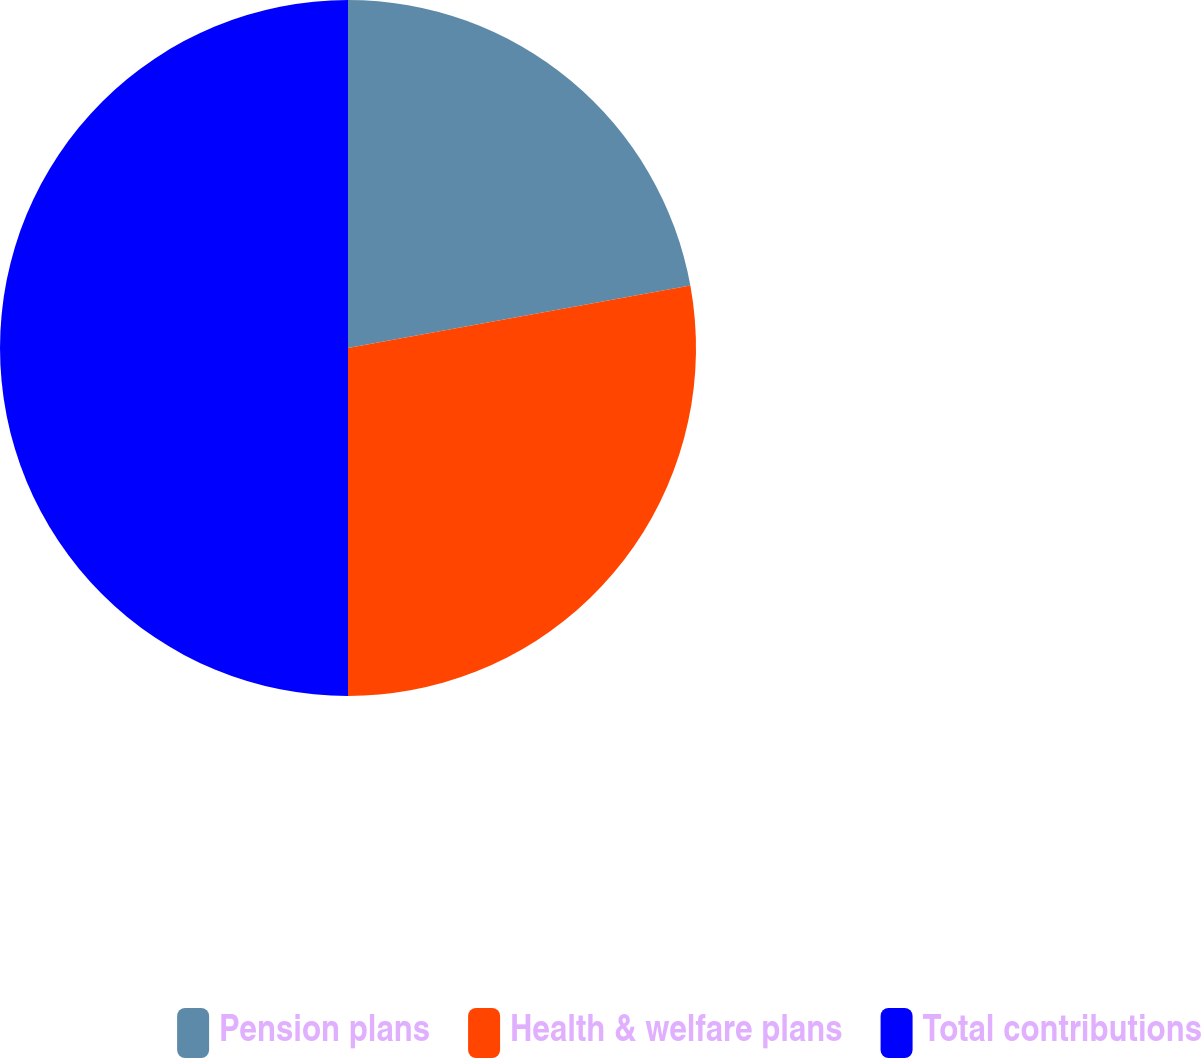Convert chart to OTSL. <chart><loc_0><loc_0><loc_500><loc_500><pie_chart><fcel>Pension plans<fcel>Health & welfare plans<fcel>Total contributions<nl><fcel>22.13%<fcel>27.87%<fcel>50.0%<nl></chart> 